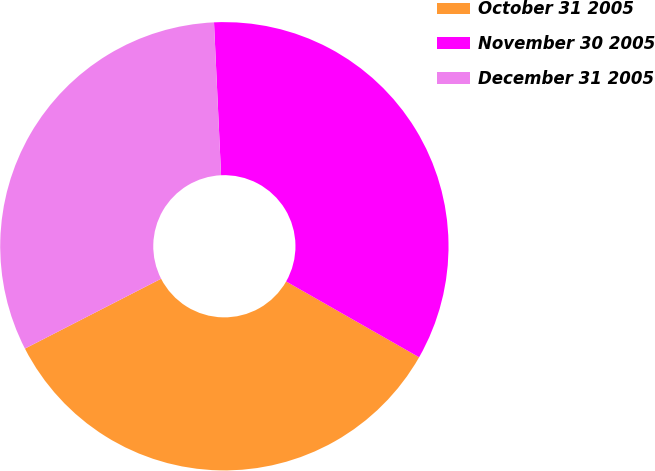Convert chart. <chart><loc_0><loc_0><loc_500><loc_500><pie_chart><fcel>October 31 2005<fcel>November 30 2005<fcel>December 31 2005<nl><fcel>34.21%<fcel>33.98%<fcel>31.81%<nl></chart> 